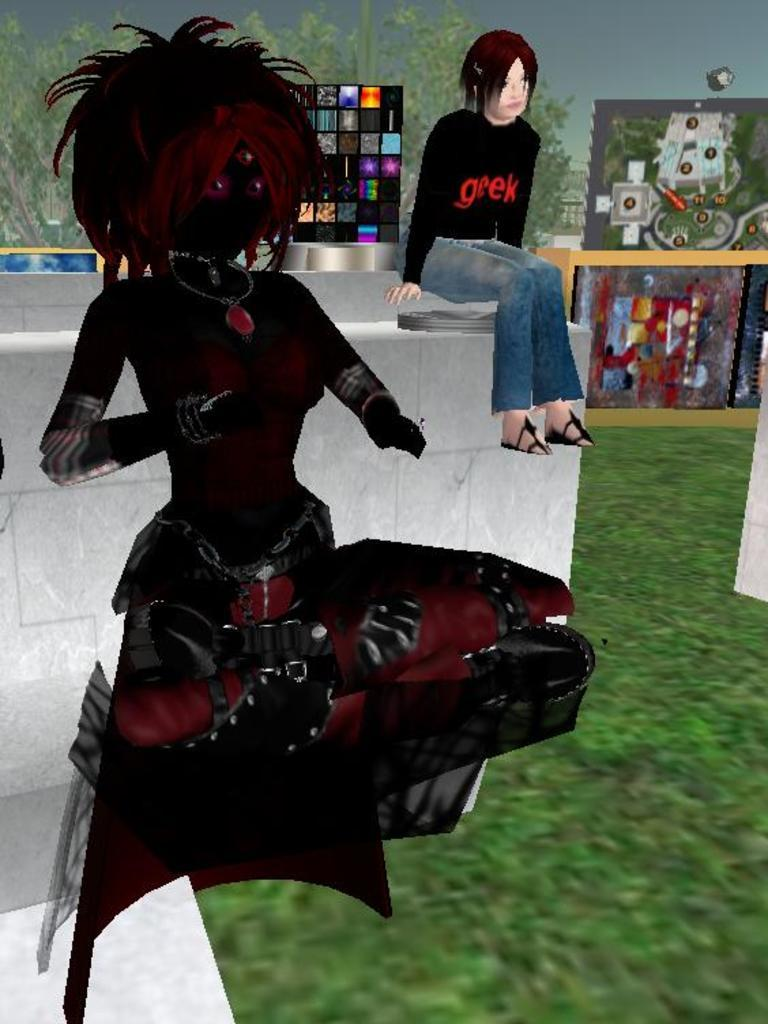Who or what is depicted in the image? There are two cartoon people sitting in the image. What can be seen in the background of the image? There are boards and trees visible in the background. What is the color of the floor in the image? The floor is in green color. How many spoons are there in the image? There are no spoons present in the image. What type of cemetery can be seen in the background of the image? There is no cemetery present in the image; it features cartoon people sitting and a background with boards and trees. 